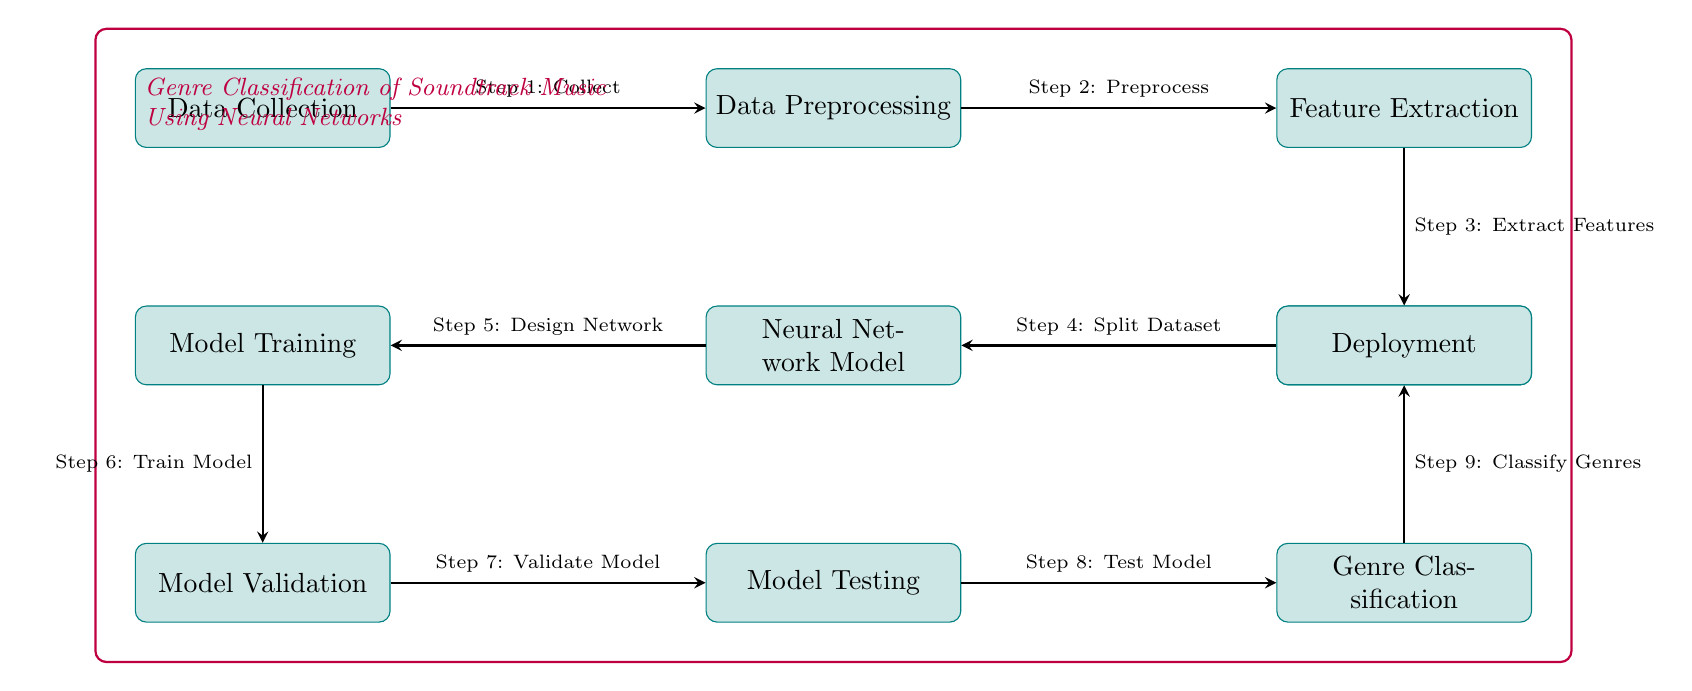What is the first step in the process? The first step in the process is labeled as "Data Collection," which is the initial node in the diagram that initiates the genre classification pipeline.
Answer: Data Collection How many processes are depicted in the diagram? By counting all the nodes that represent processes in the diagram, we find there are ten processes indicated by the labeled rectangles.
Answer: ten What is the output of the "Model Testing"? The output of "Model Testing" leads to the next step, which is "Genre Classification" according to the directional flow of the diagram.
Answer: Genre Classification What comes after "Model Validation"? The process that follows "Model Validation" in the diagram is "Model Testing," as indicated by the direction of the arrow leading from one node to the next.
Answer: Model Testing Which process is directly connected to "Neural Network Model"? Directly connected to "Neural Network Model" through the arrow is the process "Model Training," making it the immediate next step in the sequence.
Answer: Model Training Explain the relationship between "Data Preprocessing" and "Feature Extraction". "Data Preprocessing" comes directly before "Feature Extraction," with an arrow connecting them, indicating that preprocessing is a necessary step before feature extraction can take place.
Answer: Precedes What is the purpose of the "Deployment" process? The purpose of "Deployment" is to take the output from "Genre Classification" and implement the model in a practical setting, as it's the last step in the flow.
Answer: Implementing the model Which step is responsible for splitting the dataset? The step that is responsible for splitting the dataset is clearly labeled as "Dataset Splitting," positioned directly below "Feature Extraction" in the diagram.
Answer: Dataset Splitting What is meant by "Genre Classification"? "Genre Classification" refers to the final step in the process that assigns various genres to the soundtracks based on the model's analysis, as indicated in the diagram.
Answer: Assigns genres 